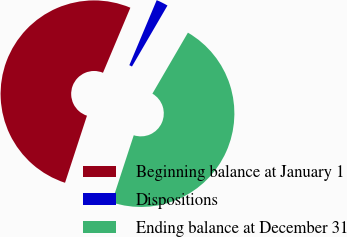Convert chart. <chart><loc_0><loc_0><loc_500><loc_500><pie_chart><fcel>Beginning balance at January 1<fcel>Dispositions<fcel>Ending balance at December 31<nl><fcel>51.31%<fcel>2.05%<fcel>46.64%<nl></chart> 